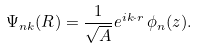<formula> <loc_0><loc_0><loc_500><loc_500>\Psi _ { n { k } } ( { R } ) = \frac { 1 } { \sqrt { A } } e ^ { i { k \cdot r } } \, \phi _ { n } ( z ) .</formula> 